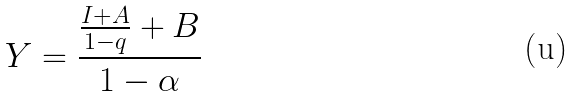<formula> <loc_0><loc_0><loc_500><loc_500>Y = \frac { \frac { I + A } { 1 - q } + B } { 1 - \alpha }</formula> 